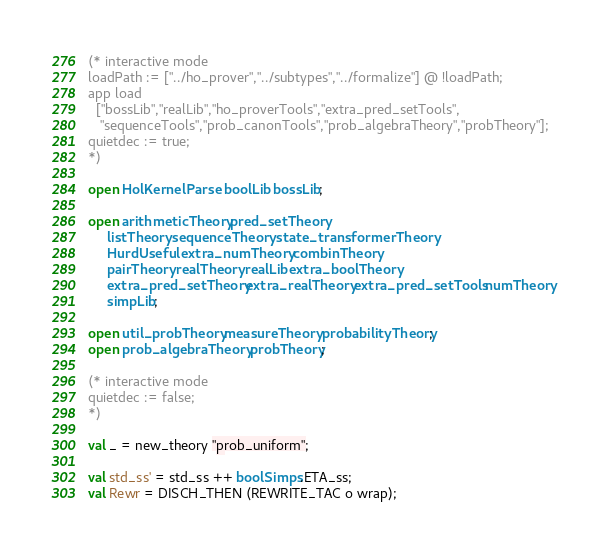Convert code to text. <code><loc_0><loc_0><loc_500><loc_500><_SML_>(* interactive mode
loadPath := ["../ho_prover","../subtypes","../formalize"] @ !loadPath;
app load
  ["bossLib","realLib","ho_proverTools","extra_pred_setTools",
   "sequenceTools","prob_canonTools","prob_algebraTheory","probTheory"];
quietdec := true;
*)

open HolKernel Parse boolLib bossLib;

open arithmeticTheory pred_setTheory
     listTheory sequenceTheory state_transformerTheory
     HurdUseful extra_numTheory combinTheory
     pairTheory realTheory realLib extra_boolTheory
     extra_pred_setTheory extra_realTheory extra_pred_setTools numTheory
     simpLib;

open util_probTheory measureTheory probabilityTheory;
open prob_algebraTheory probTheory;

(* interactive mode
quietdec := false;
*)

val _ = new_theory "prob_uniform";

val std_ss' = std_ss ++ boolSimps.ETA_ss;
val Rewr = DISCH_THEN (REWRITE_TAC o wrap);</code> 